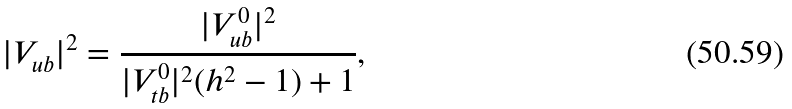Convert formula to latex. <formula><loc_0><loc_0><loc_500><loc_500>| V _ { u b } | ^ { 2 } = \frac { | V ^ { 0 } _ { u b } | ^ { 2 } } { | V ^ { 0 } _ { t b } | ^ { 2 } ( h ^ { 2 } - 1 ) + 1 } ,</formula> 